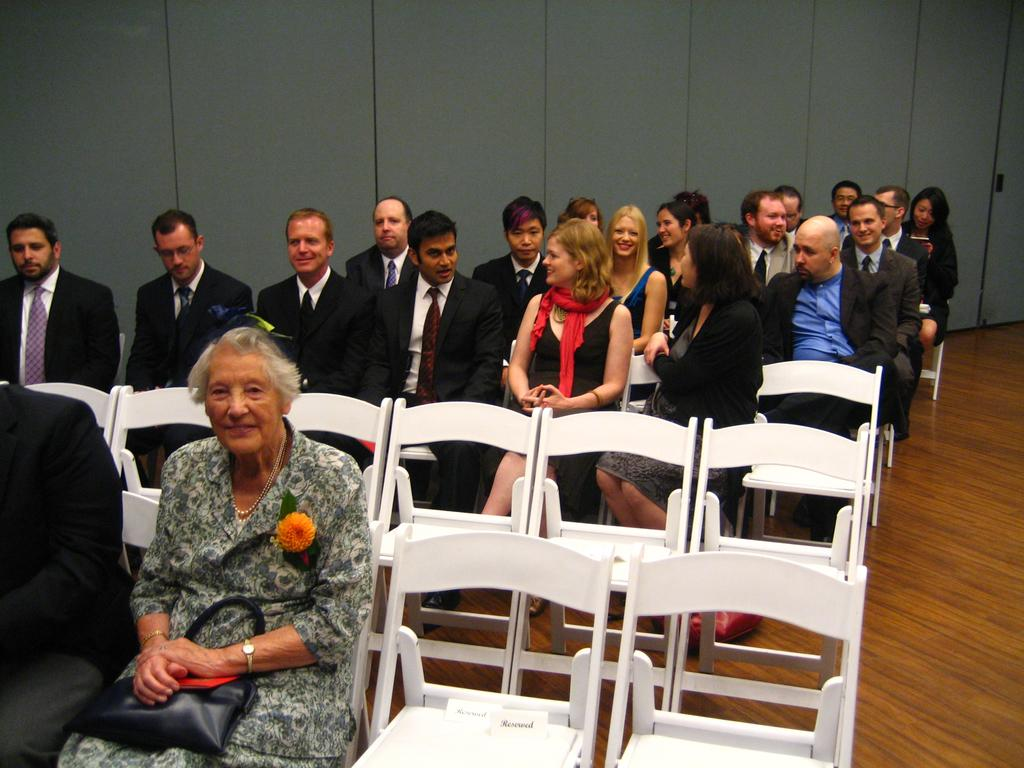What are the people in the image doing? There is a group of people sitting on chairs, suggesting they are sitting. Can you describe the woman in the image? The woman is carrying a bag and wearing a scarf. What is the attire of most people in the image? Most of the people are wearing black suits and ties. What color are the chairs in the image? The chairs are white in color. Is there a family standing on the dock at the end of the image? There is no dock or family present in the image; it features a group of people sitting on chairs. 